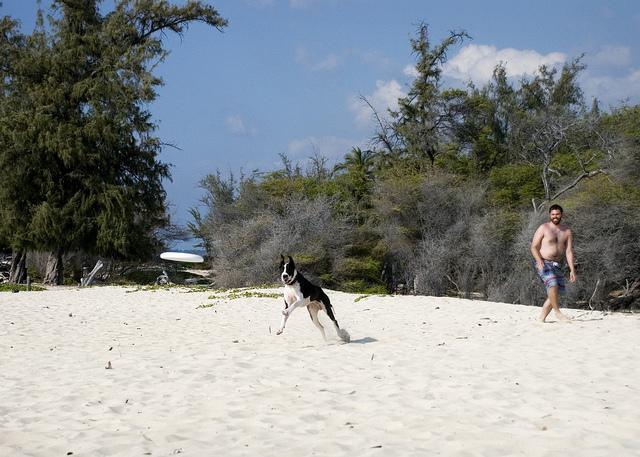How many people are there?
Give a very brief answer. 1. 